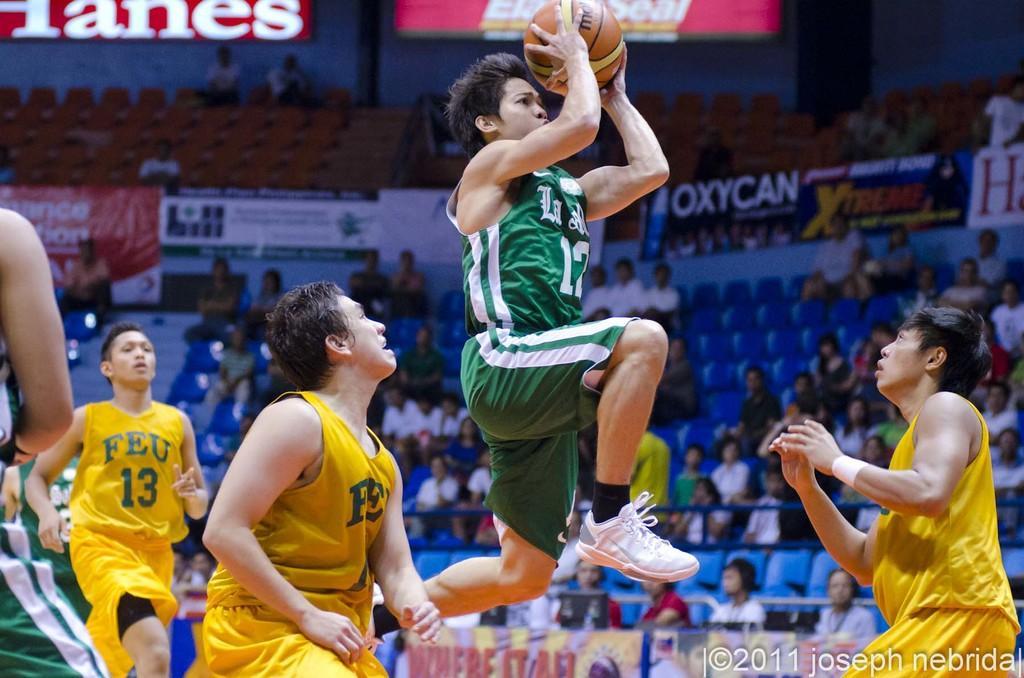Can you describe this image briefly? The players are playing basketball in the ground and they are wearing green and yellow costumes, around the ground some people are sitting and watching the game and there is a fencing around the ground with the name of sponsors. 